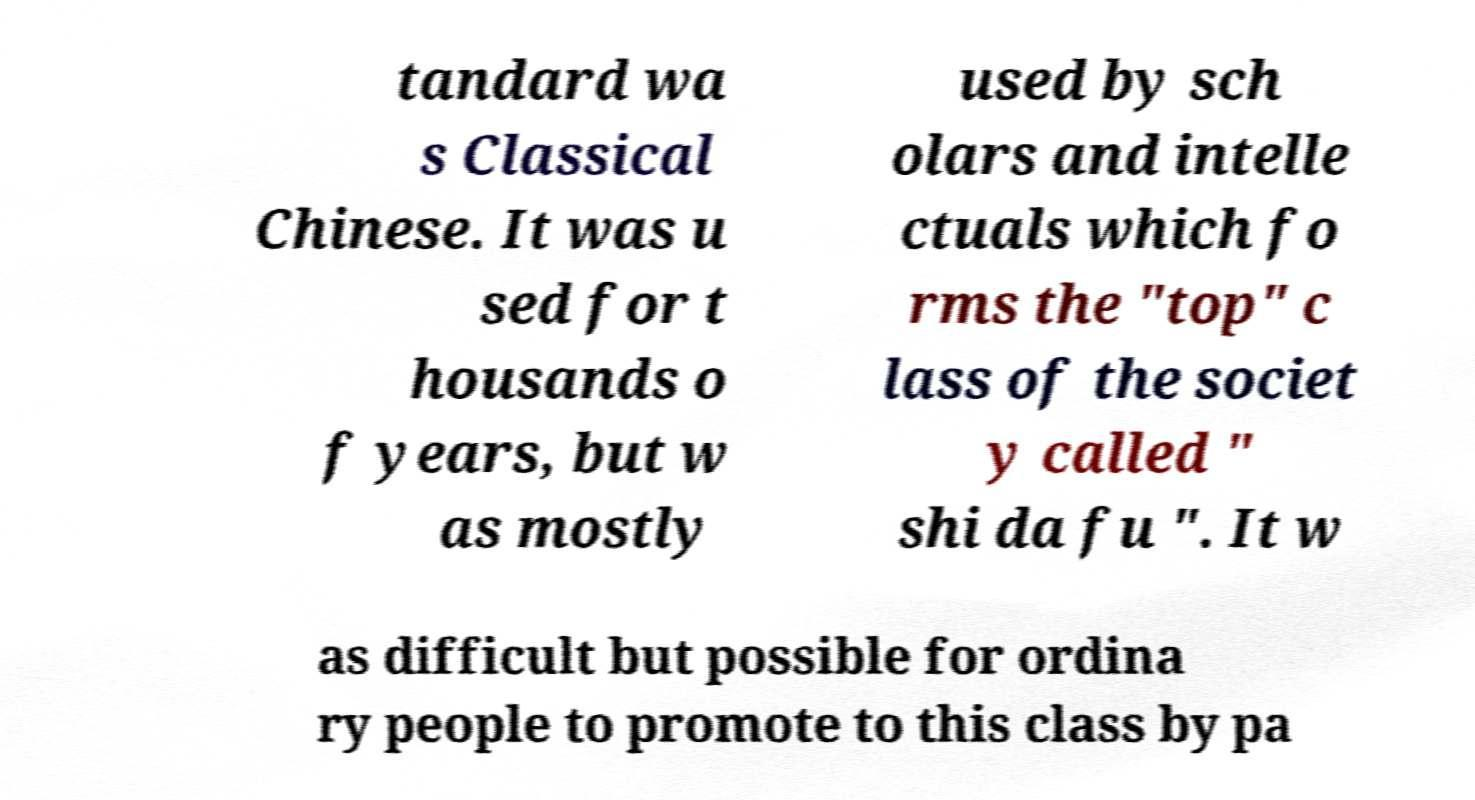Can you read and provide the text displayed in the image?This photo seems to have some interesting text. Can you extract and type it out for me? tandard wa s Classical Chinese. It was u sed for t housands o f years, but w as mostly used by sch olars and intelle ctuals which fo rms the "top" c lass of the societ y called " shi da fu ". It w as difficult but possible for ordina ry people to promote to this class by pa 